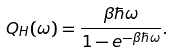<formula> <loc_0><loc_0><loc_500><loc_500>Q _ { H } ( \omega ) = \frac { \beta \hbar { \omega } } { 1 - e ^ { - \beta \hbar { \omega } } } .</formula> 